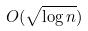Convert formula to latex. <formula><loc_0><loc_0><loc_500><loc_500>O ( \sqrt { \log n } )</formula> 